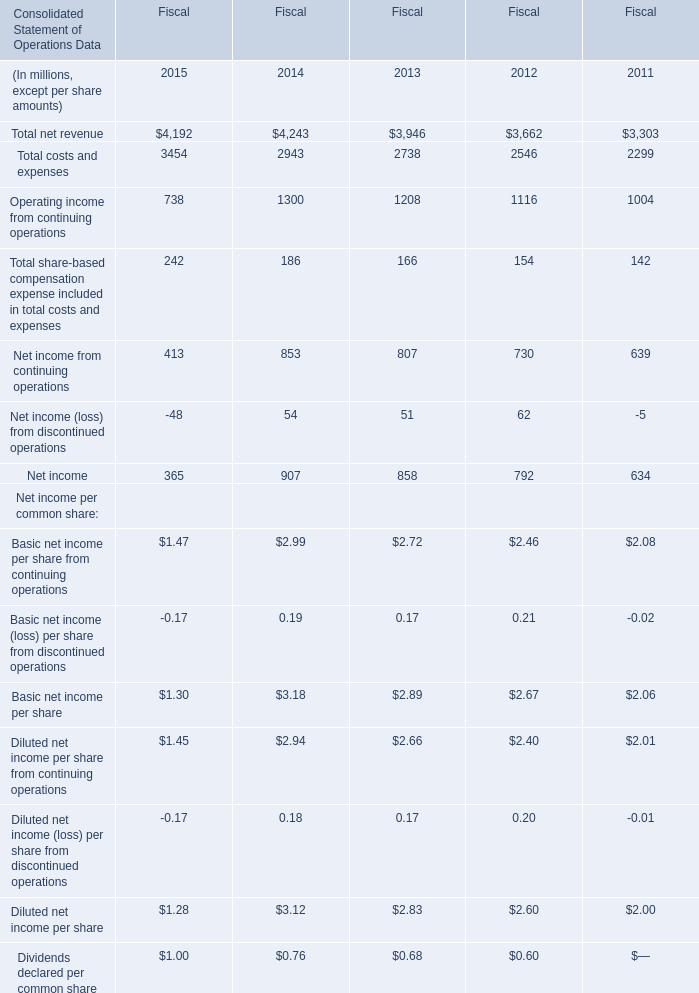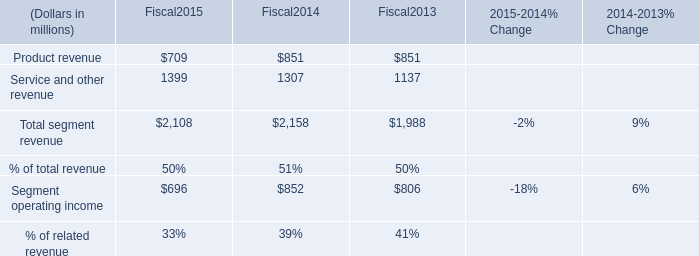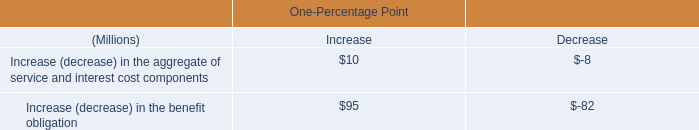In the year with the most Net income, what is the growth rate of Net income from continuing operations? 
Computations: ((853 - 807) / 807)
Answer: 0.057. 